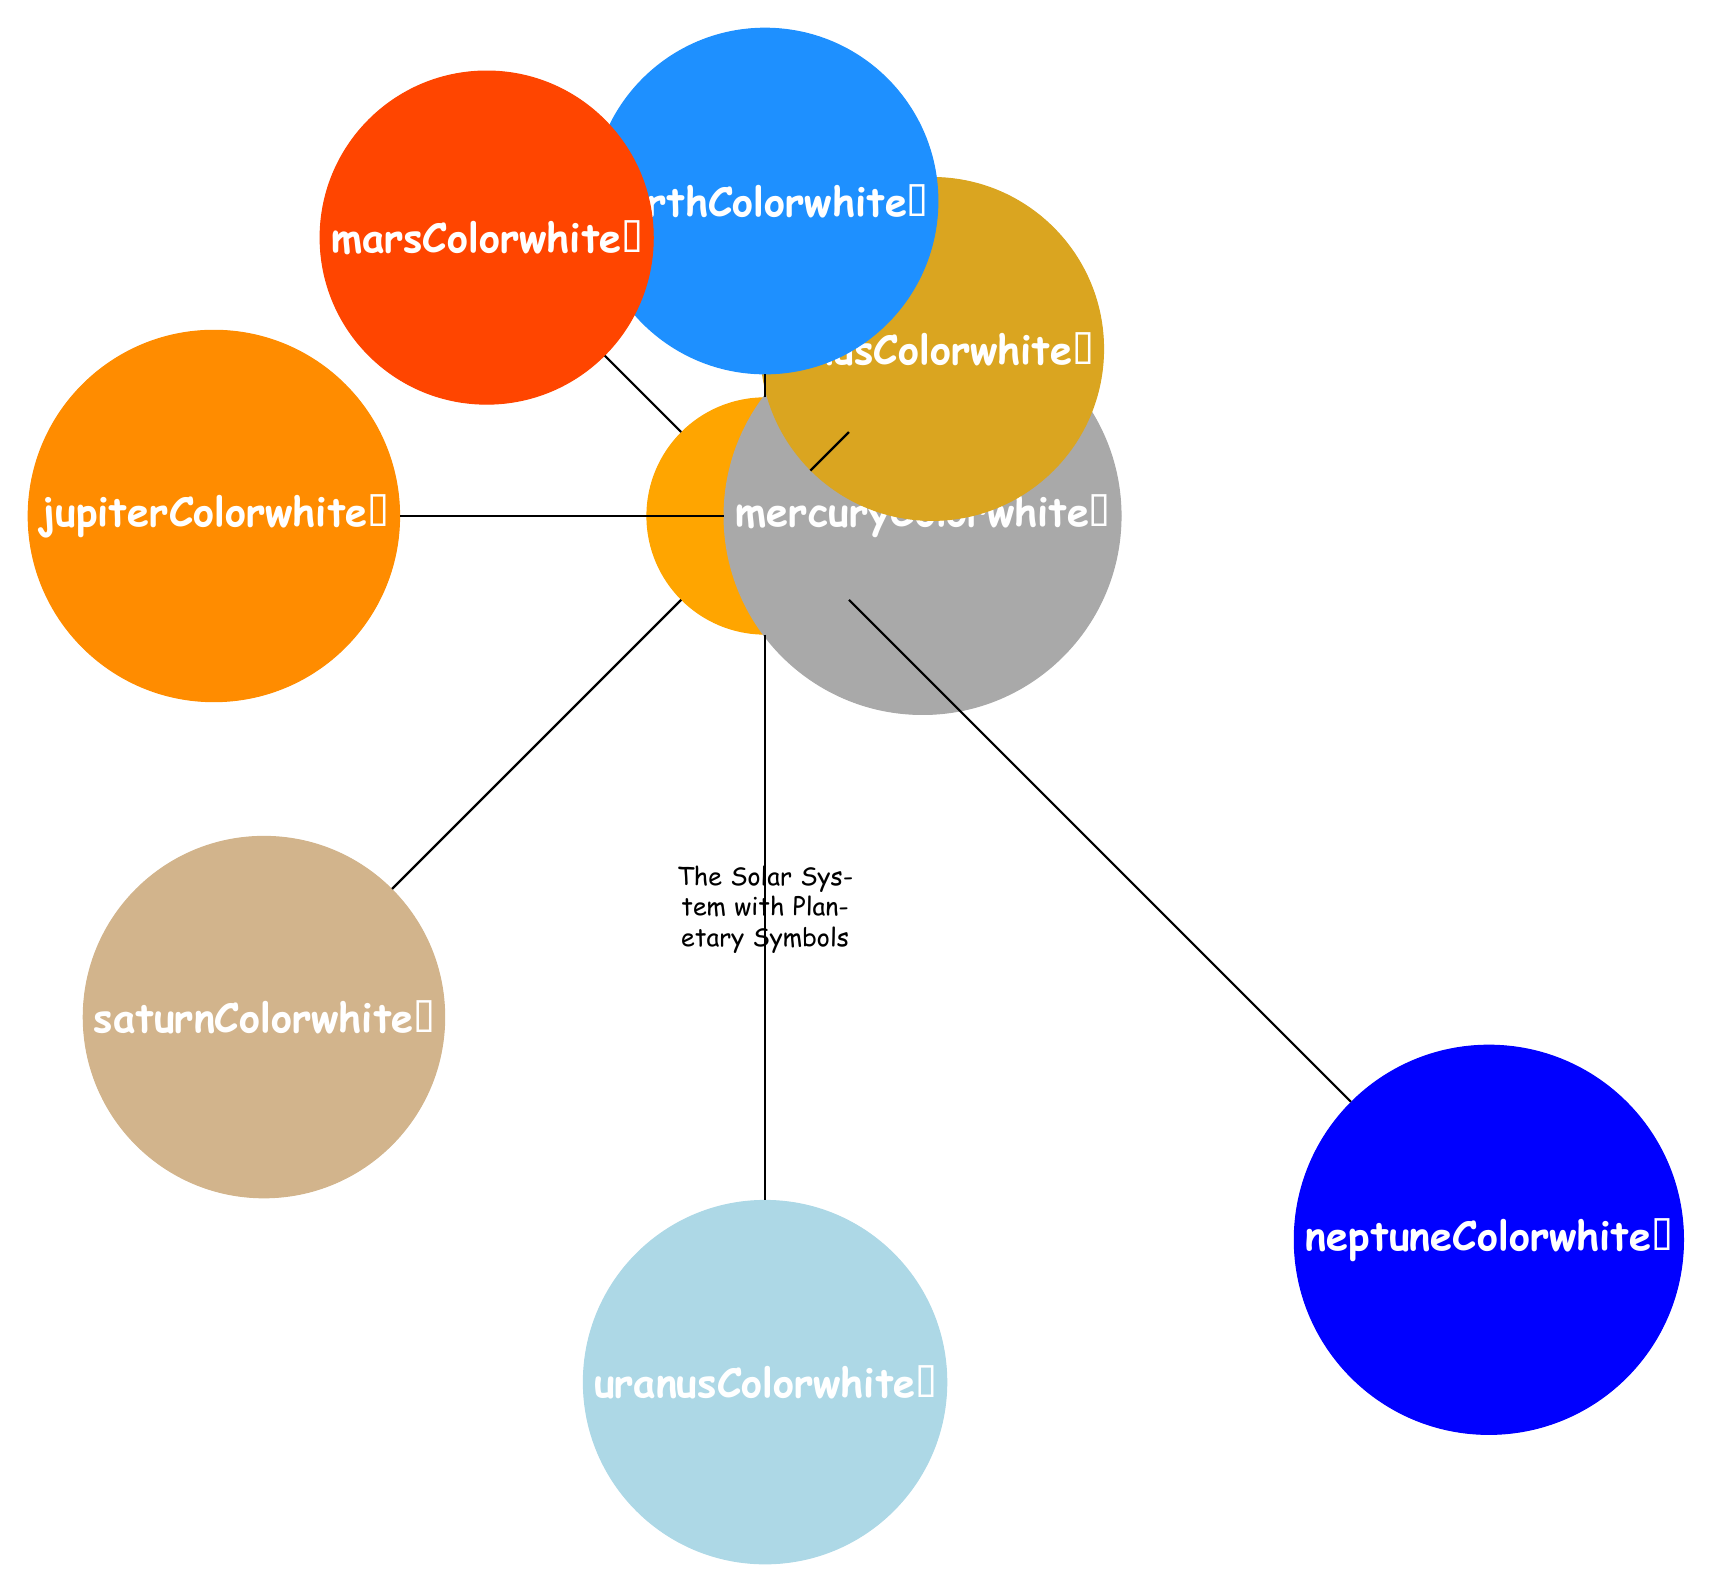What is the symbol for Mars? The symbol for Mars is listed in the data under the 'mars' entry, which is represented by the character '♂'.
Answer: ♂ What color is the planet Venus? By checking the data in the diagram, Venus is associated with the color defined as 'venusColor'. In the RGB values, this corresponds to a golden yellow color.
Answer: Golden yellow How many planets are represented in the diagram? By counting the planets defined in the data section of the code, there are eight entries corresponding to the planets Mercury, Venus, Earth, Mars, Jupiter, Saturn, Uranus, and Neptune.
Answer: Eight Which planet is the furthest from the Sun? The diagram arranges the planets in a circular layout, and according to the distance defined, Neptune is represented as the furthest planet from the Sun.
Answer: Neptune What is the distance of Jupiter from the Sun? The distance of Jupiter is provided in the code as '7', which quantitatively indicates its position relative to the Sun in the diagram.
Answer: 7 Which planet has the symbol that resembles a circle with a cross? Reviewing the symbols outlined in the data, the planet Earth is represented by the symbol '♁', which visually matches the description of a circle with a cross.
Answer: Earth What is the angle of Saturn's position in the diagram? Saturn's position is denoted in the data with an angle of '225', reflecting its position relative to the Sun in the circular arrangement.
Answer: 225 Which planet is represented by the symbol of a planet with a ring? The symbol for Saturn, which is represented as '♄', is iconic for its rings, making it the correct answer.
Answer: Saturn What is the main theme of the diagram? The key theme depicted in the diagram is "The Solar System with Planetary Symbols," which illustrates the solar system using unique symbols and artistic representation.
Answer: The Solar System with Planetary Symbols 